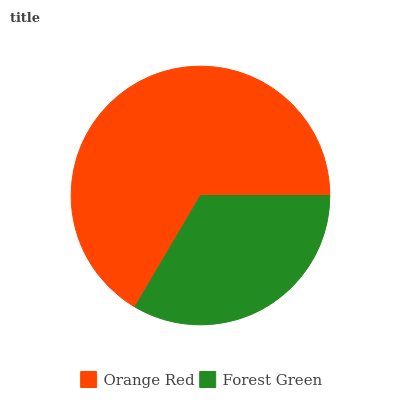Is Forest Green the minimum?
Answer yes or no. Yes. Is Orange Red the maximum?
Answer yes or no. Yes. Is Forest Green the maximum?
Answer yes or no. No. Is Orange Red greater than Forest Green?
Answer yes or no. Yes. Is Forest Green less than Orange Red?
Answer yes or no. Yes. Is Forest Green greater than Orange Red?
Answer yes or no. No. Is Orange Red less than Forest Green?
Answer yes or no. No. Is Orange Red the high median?
Answer yes or no. Yes. Is Forest Green the low median?
Answer yes or no. Yes. Is Forest Green the high median?
Answer yes or no. No. Is Orange Red the low median?
Answer yes or no. No. 